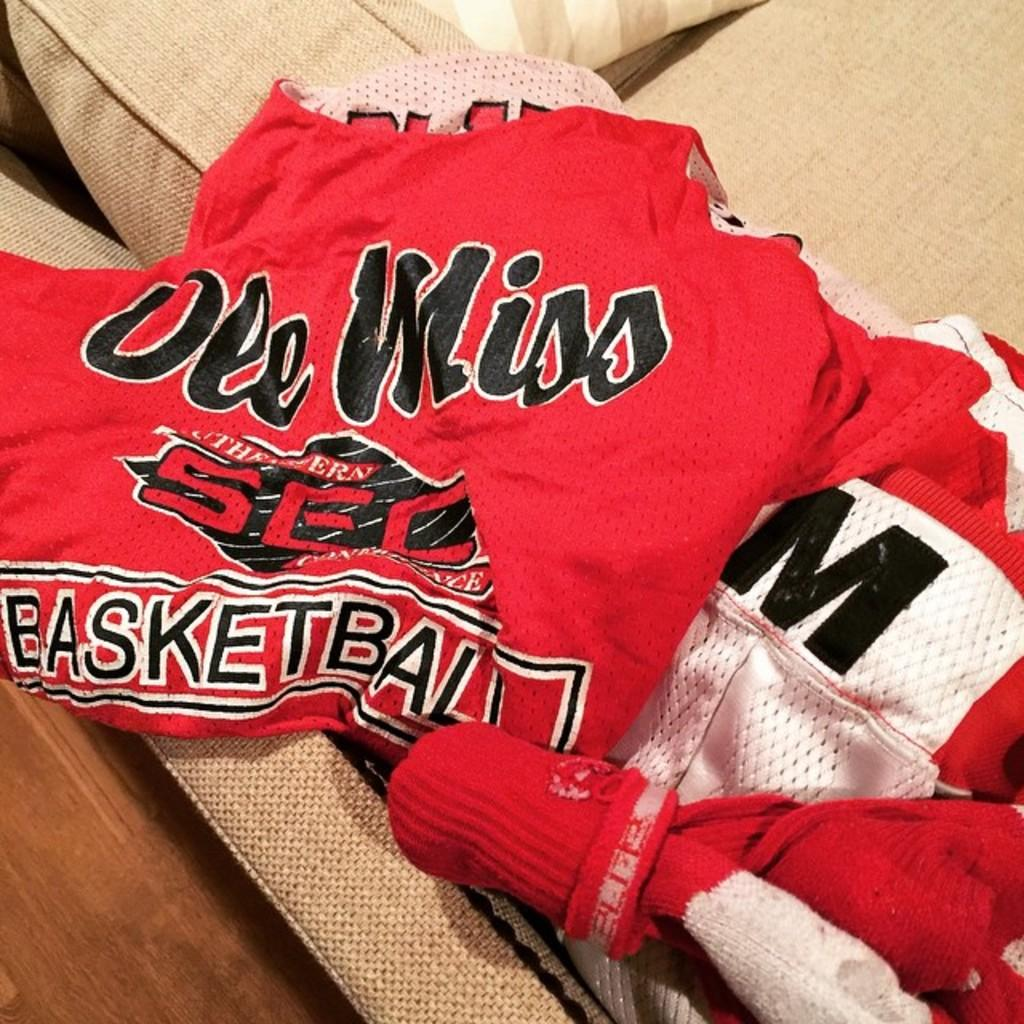<image>
Write a terse but informative summary of the picture. a red shirt has the word basketball on it. 